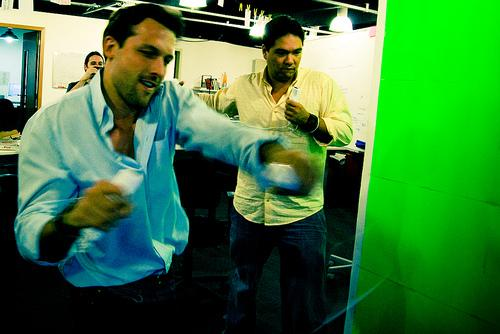What activity is the individual engaging in? Please explain your reasoning. boxing. The person is boxing because he has a boxer's stance 